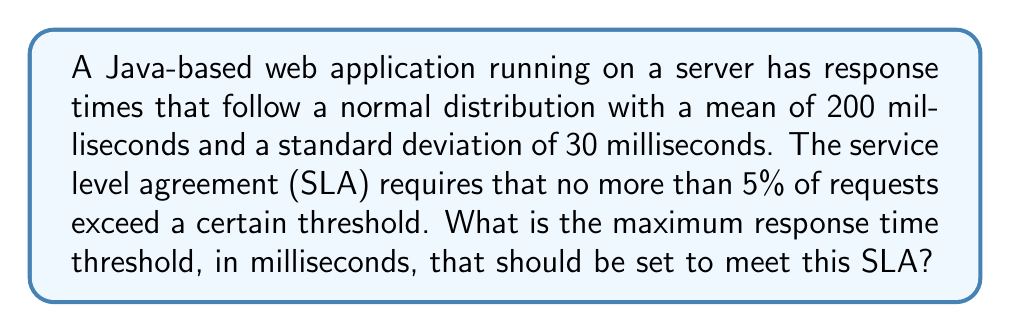Provide a solution to this math problem. To solve this problem, we need to use the properties of the normal distribution and the concept of z-scores.

Step 1: Identify the given information
- Response times follow a normal distribution
- Mean (μ) = 200 ms
- Standard deviation (σ) = 30 ms
- We need to find the threshold where 95% of requests are below it (since 5% can exceed)

Step 2: Determine the z-score for the 95th percentile
The z-score for the 95th percentile is 1.645 (from the standard normal distribution table)

Step 3: Use the z-score formula to calculate the threshold
The z-score formula is:
$$ z = \frac{x - \mu}{\sigma} $$

Where:
z = 1.645 (95th percentile)
x = threshold we're looking for
μ = 200 ms
σ = 30 ms

Rearranging the formula to solve for x:
$$ x = \mu + z\sigma $$

Step 4: Plug in the values and calculate
$$ x = 200 + 1.645 * 30 $$
$$ x = 200 + 49.35 $$
$$ x = 249.35 $$

Step 5: Round to the nearest millisecond
x ≈ 249 ms

Therefore, the maximum response time threshold should be set to 249 ms to ensure that no more than 5% of requests exceed this limit.
Answer: 249 ms 